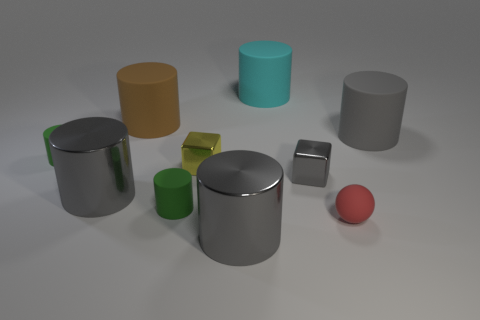How many gray cylinders must be subtracted to get 1 gray cylinders? 2 Subtract all yellow cubes. How many gray cylinders are left? 3 Subtract all big cyan cylinders. How many cylinders are left? 6 Subtract all green cylinders. How many cylinders are left? 5 Subtract all red cylinders. Subtract all red balls. How many cylinders are left? 7 Subtract all blocks. How many objects are left? 8 Add 1 large gray cylinders. How many large gray cylinders exist? 4 Subtract 0 brown cubes. How many objects are left? 10 Subtract all large cyan cylinders. Subtract all cylinders. How many objects are left? 2 Add 1 gray things. How many gray things are left? 5 